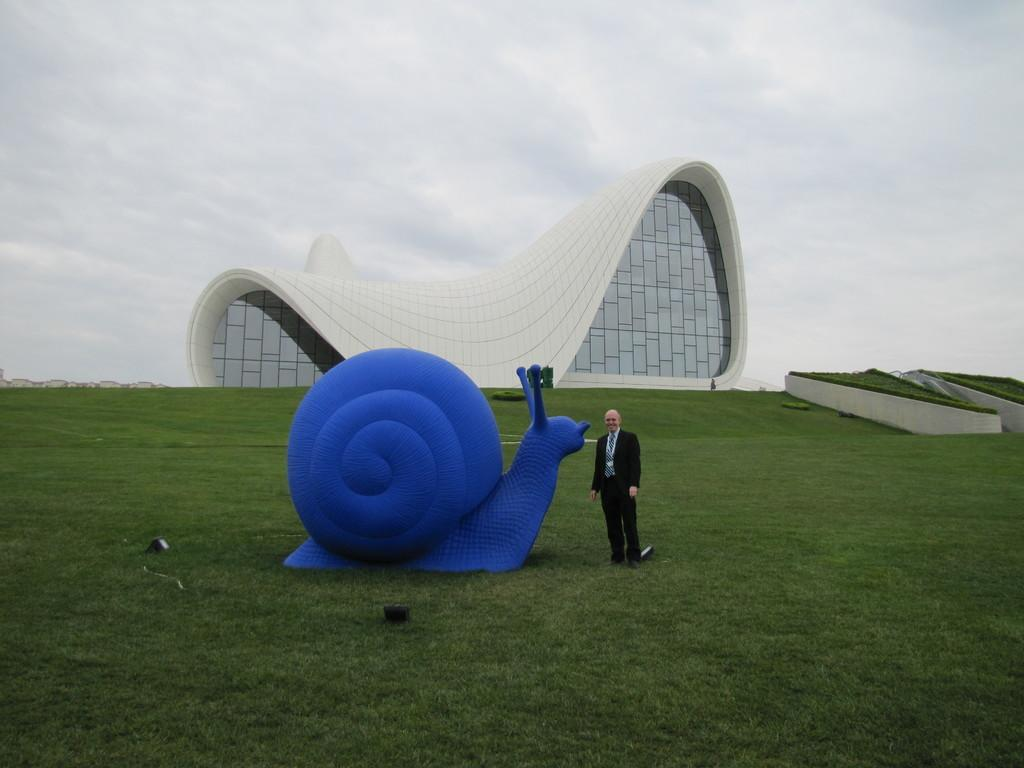What is the main subject of the image? The main subject of the image is a snail statue. Who or what is standing beside the snail statue? There is a man standing beside the snail statue. What can be seen in the background of the image? There is a building in the background of the image. What type of windows does the building have? The building has glass windows. What is the condition of the sky in the image? The sky is clear in the image. How much lettuce does the snail statue consume in the image? The snail statue is not a real snail and therefore cannot consume lettuce or any other food. 